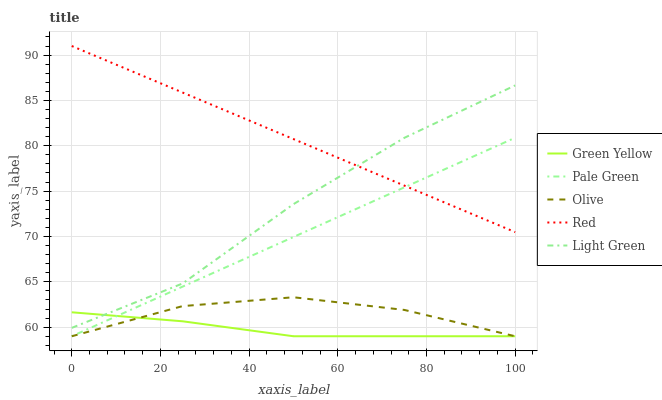Does Green Yellow have the minimum area under the curve?
Answer yes or no. Yes. Does Red have the maximum area under the curve?
Answer yes or no. Yes. Does Pale Green have the minimum area under the curve?
Answer yes or no. No. Does Pale Green have the maximum area under the curve?
Answer yes or no. No. Is Pale Green the smoothest?
Answer yes or no. Yes. Is Light Green the roughest?
Answer yes or no. Yes. Is Green Yellow the smoothest?
Answer yes or no. No. Is Green Yellow the roughest?
Answer yes or no. No. Does Olive have the lowest value?
Answer yes or no. Yes. Does Light Green have the lowest value?
Answer yes or no. No. Does Red have the highest value?
Answer yes or no. Yes. Does Pale Green have the highest value?
Answer yes or no. No. Is Olive less than Light Green?
Answer yes or no. Yes. Is Red greater than Olive?
Answer yes or no. Yes. Does Light Green intersect Green Yellow?
Answer yes or no. Yes. Is Light Green less than Green Yellow?
Answer yes or no. No. Is Light Green greater than Green Yellow?
Answer yes or no. No. Does Olive intersect Light Green?
Answer yes or no. No. 